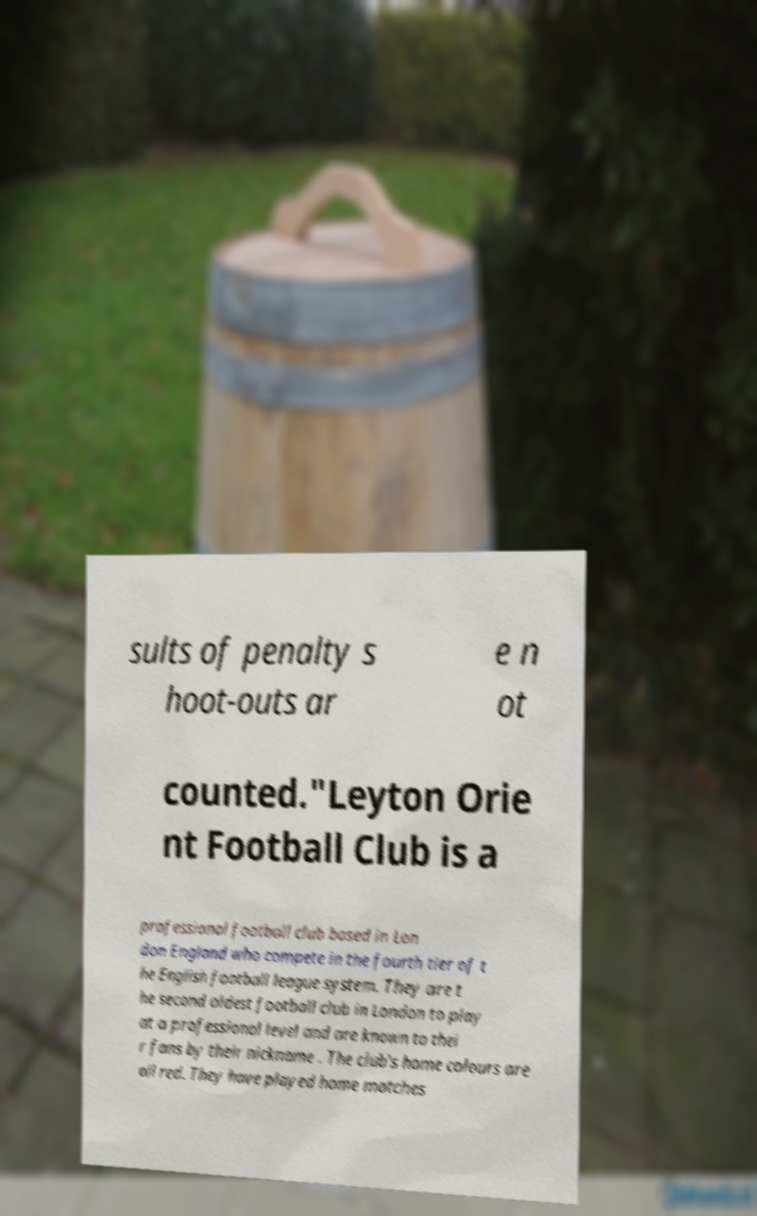Could you assist in decoding the text presented in this image and type it out clearly? sults of penalty s hoot-outs ar e n ot counted."Leyton Orie nt Football Club is a professional football club based in Lon don England who compete in the fourth tier of t he English football league system. They are t he second oldest football club in London to play at a professional level and are known to thei r fans by their nickname . The club's home colours are all red. They have played home matches 